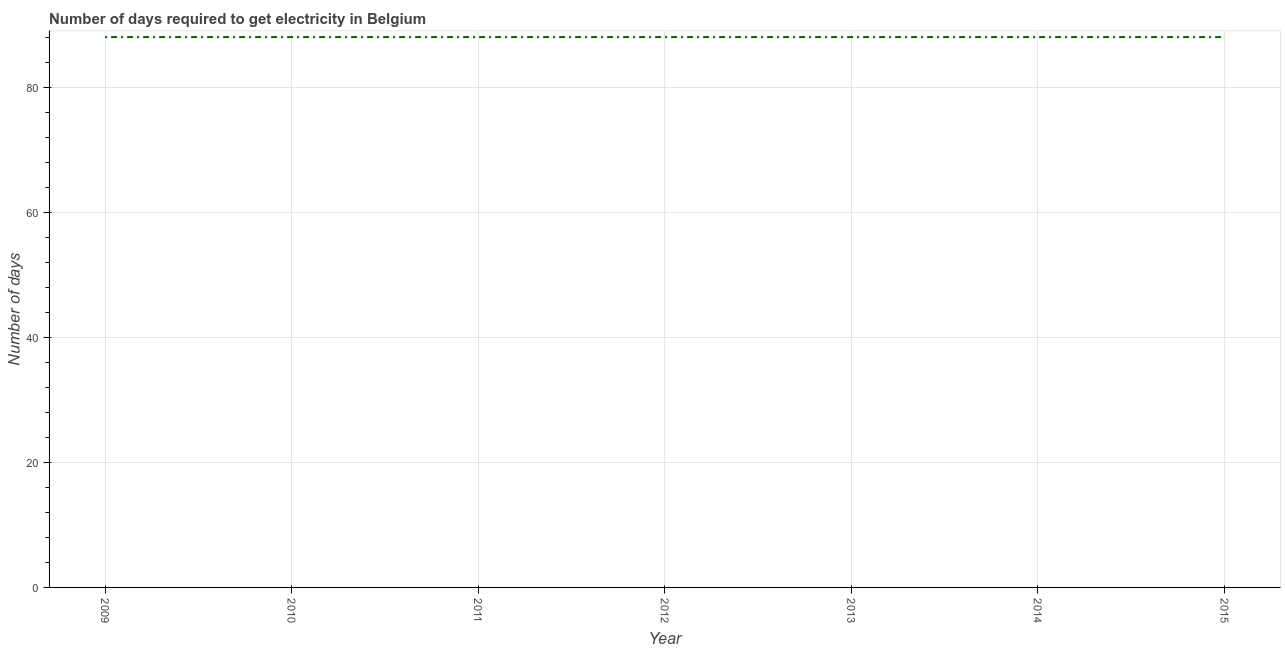What is the time to get electricity in 2012?
Give a very brief answer. 88. Across all years, what is the maximum time to get electricity?
Your answer should be compact. 88. Across all years, what is the minimum time to get electricity?
Offer a terse response. 88. In which year was the time to get electricity minimum?
Your answer should be very brief. 2009. What is the sum of the time to get electricity?
Your response must be concise. 616. What is the average time to get electricity per year?
Offer a terse response. 88. In how many years, is the time to get electricity greater than 16 ?
Your answer should be very brief. 7. Do a majority of the years between 2013 and 2011 (inclusive) have time to get electricity greater than 64 ?
Provide a succinct answer. No. Is the difference between the time to get electricity in 2010 and 2014 greater than the difference between any two years?
Make the answer very short. Yes. Does the time to get electricity monotonically increase over the years?
Provide a short and direct response. No. How many years are there in the graph?
Your response must be concise. 7. What is the difference between two consecutive major ticks on the Y-axis?
Offer a very short reply. 20. Does the graph contain any zero values?
Make the answer very short. No. What is the title of the graph?
Ensure brevity in your answer.  Number of days required to get electricity in Belgium. What is the label or title of the X-axis?
Your answer should be compact. Year. What is the label or title of the Y-axis?
Make the answer very short. Number of days. What is the Number of days of 2009?
Give a very brief answer. 88. What is the Number of days of 2010?
Make the answer very short. 88. What is the Number of days in 2015?
Provide a short and direct response. 88. What is the difference between the Number of days in 2009 and 2010?
Offer a terse response. 0. What is the difference between the Number of days in 2009 and 2011?
Provide a short and direct response. 0. What is the difference between the Number of days in 2009 and 2014?
Ensure brevity in your answer.  0. What is the difference between the Number of days in 2010 and 2014?
Your answer should be very brief. 0. What is the difference between the Number of days in 2011 and 2012?
Make the answer very short. 0. What is the difference between the Number of days in 2011 and 2013?
Keep it short and to the point. 0. What is the difference between the Number of days in 2011 and 2014?
Your answer should be very brief. 0. What is the difference between the Number of days in 2011 and 2015?
Ensure brevity in your answer.  0. What is the difference between the Number of days in 2012 and 2013?
Offer a terse response. 0. What is the difference between the Number of days in 2012 and 2015?
Offer a terse response. 0. What is the difference between the Number of days in 2013 and 2015?
Give a very brief answer. 0. What is the difference between the Number of days in 2014 and 2015?
Your answer should be compact. 0. What is the ratio of the Number of days in 2009 to that in 2013?
Ensure brevity in your answer.  1. What is the ratio of the Number of days in 2009 to that in 2014?
Offer a terse response. 1. What is the ratio of the Number of days in 2009 to that in 2015?
Provide a short and direct response. 1. What is the ratio of the Number of days in 2010 to that in 2011?
Offer a terse response. 1. What is the ratio of the Number of days in 2010 to that in 2013?
Provide a short and direct response. 1. What is the ratio of the Number of days in 2011 to that in 2012?
Your response must be concise. 1. What is the ratio of the Number of days in 2011 to that in 2013?
Offer a terse response. 1. What is the ratio of the Number of days in 2011 to that in 2015?
Keep it short and to the point. 1. What is the ratio of the Number of days in 2012 to that in 2014?
Provide a succinct answer. 1. What is the ratio of the Number of days in 2012 to that in 2015?
Your answer should be compact. 1. What is the ratio of the Number of days in 2013 to that in 2015?
Offer a very short reply. 1. What is the ratio of the Number of days in 2014 to that in 2015?
Offer a terse response. 1. 